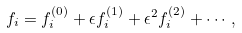Convert formula to latex. <formula><loc_0><loc_0><loc_500><loc_500>f _ { i } = f _ { i } ^ { ( 0 ) } + \epsilon f _ { i } ^ { ( 1 ) } + \epsilon ^ { 2 } f _ { i } ^ { ( 2 ) } + \cdots ,</formula> 